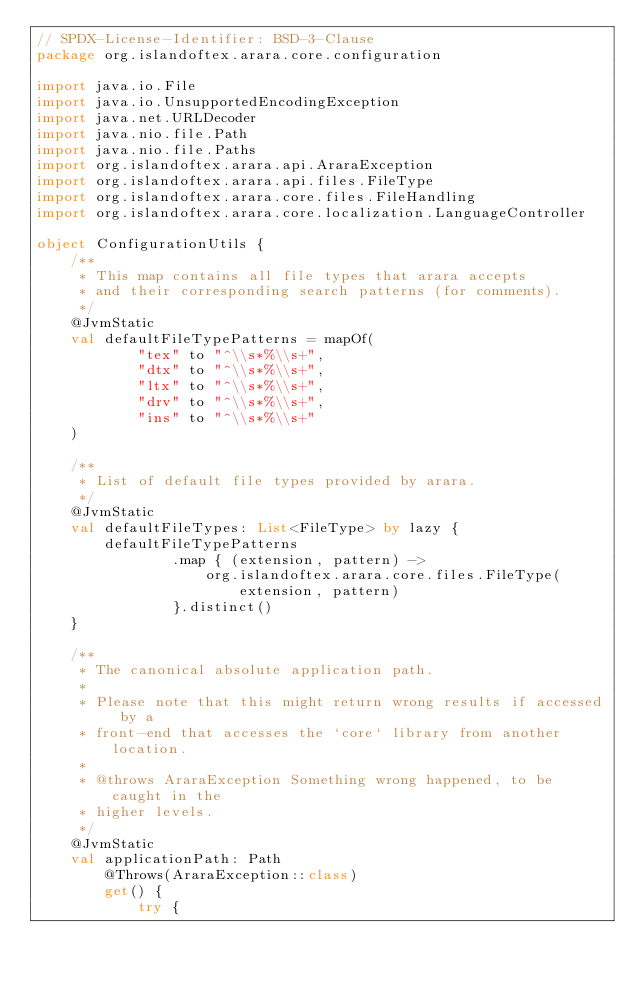<code> <loc_0><loc_0><loc_500><loc_500><_Kotlin_>// SPDX-License-Identifier: BSD-3-Clause
package org.islandoftex.arara.core.configuration

import java.io.File
import java.io.UnsupportedEncodingException
import java.net.URLDecoder
import java.nio.file.Path
import java.nio.file.Paths
import org.islandoftex.arara.api.AraraException
import org.islandoftex.arara.api.files.FileType
import org.islandoftex.arara.core.files.FileHandling
import org.islandoftex.arara.core.localization.LanguageController

object ConfigurationUtils {
    /**
     * This map contains all file types that arara accepts
     * and their corresponding search patterns (for comments).
     */
    @JvmStatic
    val defaultFileTypePatterns = mapOf(
            "tex" to "^\\s*%\\s+",
            "dtx" to "^\\s*%\\s+",
            "ltx" to "^\\s*%\\s+",
            "drv" to "^\\s*%\\s+",
            "ins" to "^\\s*%\\s+"
    )

    /**
     * List of default file types provided by arara.
     */
    @JvmStatic
    val defaultFileTypes: List<FileType> by lazy {
        defaultFileTypePatterns
                .map { (extension, pattern) ->
                    org.islandoftex.arara.core.files.FileType(extension, pattern)
                }.distinct()
    }

    /**
     * The canonical absolute application path.
     *
     * Please note that this might return wrong results if accessed by a
     * front-end that accesses the `core` library from another location.
     *
     * @throws AraraException Something wrong happened, to be caught in the
     * higher levels.
     */
    @JvmStatic
    val applicationPath: Path
        @Throws(AraraException::class)
        get() {
            try {</code> 